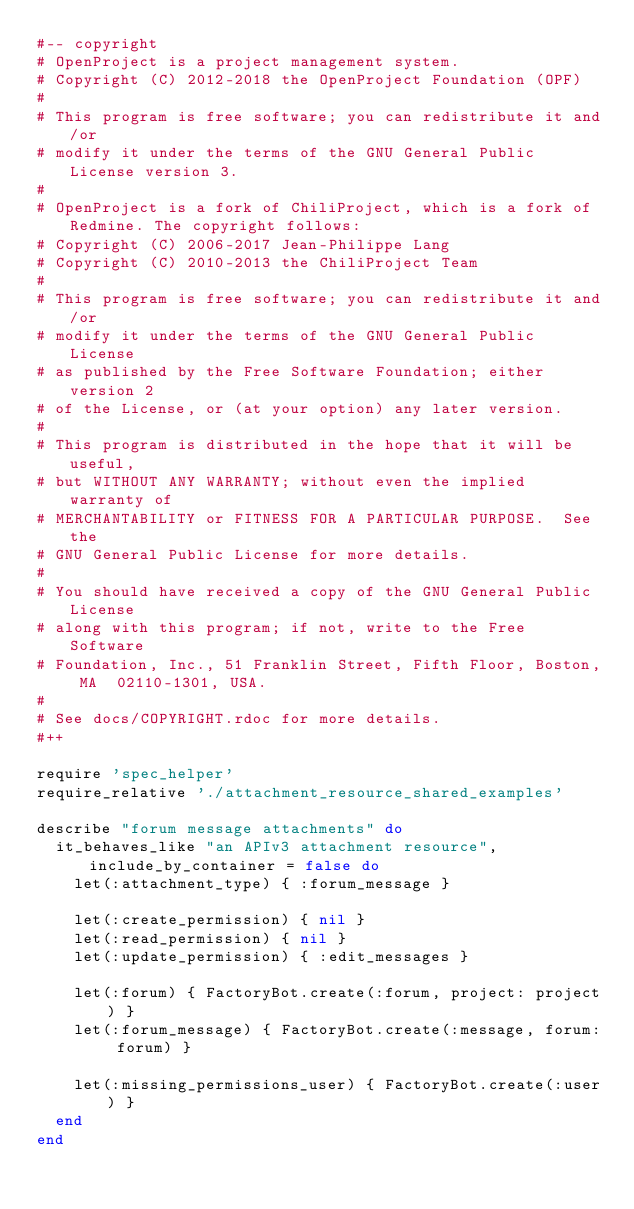<code> <loc_0><loc_0><loc_500><loc_500><_Ruby_>#-- copyright
# OpenProject is a project management system.
# Copyright (C) 2012-2018 the OpenProject Foundation (OPF)
#
# This program is free software; you can redistribute it and/or
# modify it under the terms of the GNU General Public License version 3.
#
# OpenProject is a fork of ChiliProject, which is a fork of Redmine. The copyright follows:
# Copyright (C) 2006-2017 Jean-Philippe Lang
# Copyright (C) 2010-2013 the ChiliProject Team
#
# This program is free software; you can redistribute it and/or
# modify it under the terms of the GNU General Public License
# as published by the Free Software Foundation; either version 2
# of the License, or (at your option) any later version.
#
# This program is distributed in the hope that it will be useful,
# but WITHOUT ANY WARRANTY; without even the implied warranty of
# MERCHANTABILITY or FITNESS FOR A PARTICULAR PURPOSE.  See the
# GNU General Public License for more details.
#
# You should have received a copy of the GNU General Public License
# along with this program; if not, write to the Free Software
# Foundation, Inc., 51 Franklin Street, Fifth Floor, Boston, MA  02110-1301, USA.
#
# See docs/COPYRIGHT.rdoc for more details.
#++

require 'spec_helper'
require_relative './attachment_resource_shared_examples'

describe "forum message attachments" do
  it_behaves_like "an APIv3 attachment resource", include_by_container = false do
    let(:attachment_type) { :forum_message }

    let(:create_permission) { nil }
    let(:read_permission) { nil }
    let(:update_permission) { :edit_messages }

    let(:forum) { FactoryBot.create(:forum, project: project) }
    let(:forum_message) { FactoryBot.create(:message, forum: forum) }

    let(:missing_permissions_user) { FactoryBot.create(:user) }
  end
end
</code> 